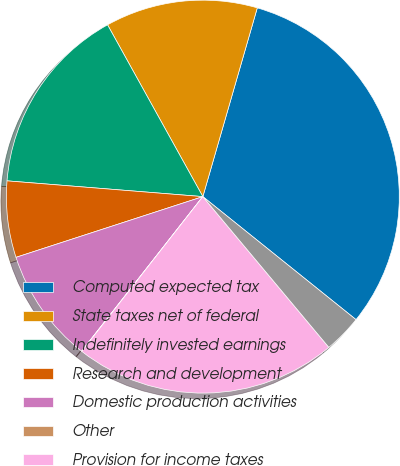<chart> <loc_0><loc_0><loc_500><loc_500><pie_chart><fcel>Computed expected tax<fcel>State taxes net of federal<fcel>Indefinitely invested earnings<fcel>Research and development<fcel>Domestic production activities<fcel>Other<fcel>Provision for income taxes<fcel>Effective tax rate<nl><fcel>31.3%<fcel>12.53%<fcel>15.66%<fcel>6.28%<fcel>9.41%<fcel>0.02%<fcel>21.65%<fcel>3.15%<nl></chart> 